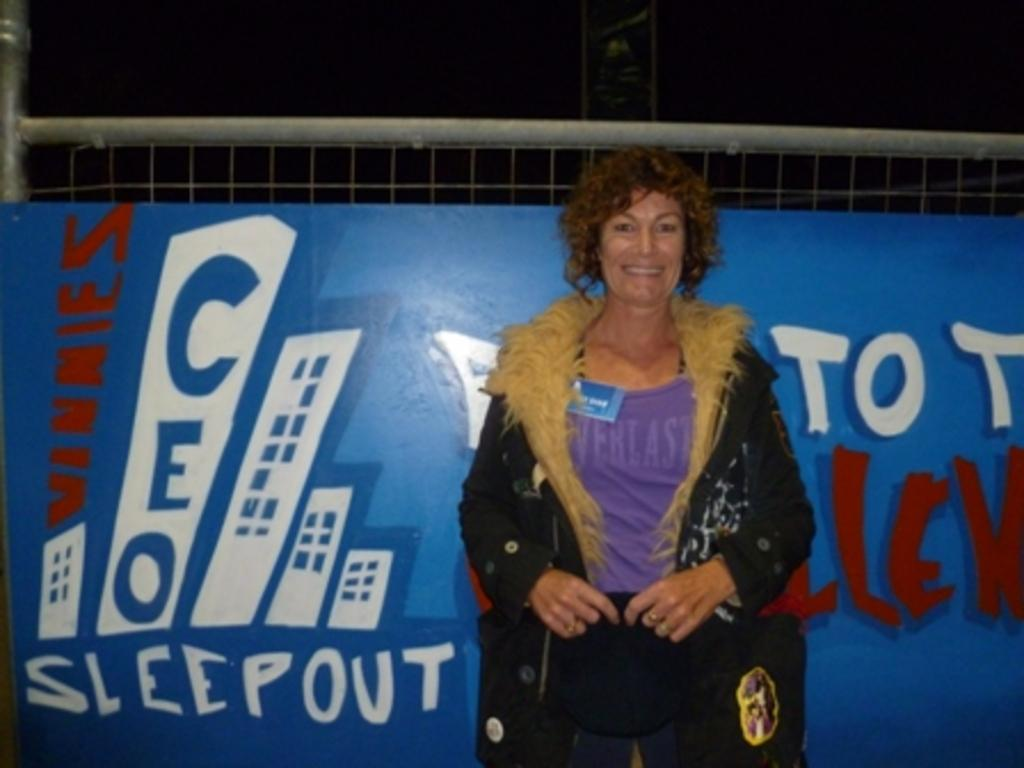What is the main subject in the foreground of the image? There is a woman in the foreground of the image. What is the woman wearing? The woman is wearing a coat. What is the woman holding in the image? The woman is holding an object. What can be seen in the background of the image? There is a blue banner and a fencing-like object in the background of the image. How would you describe the sky in the background of the image? The sky is dark in the background of the image. Can you see any squirrels climbing on the blue banner in the image? There are no squirrels visible in the image, and no squirrels are climbing on the blue banner. 